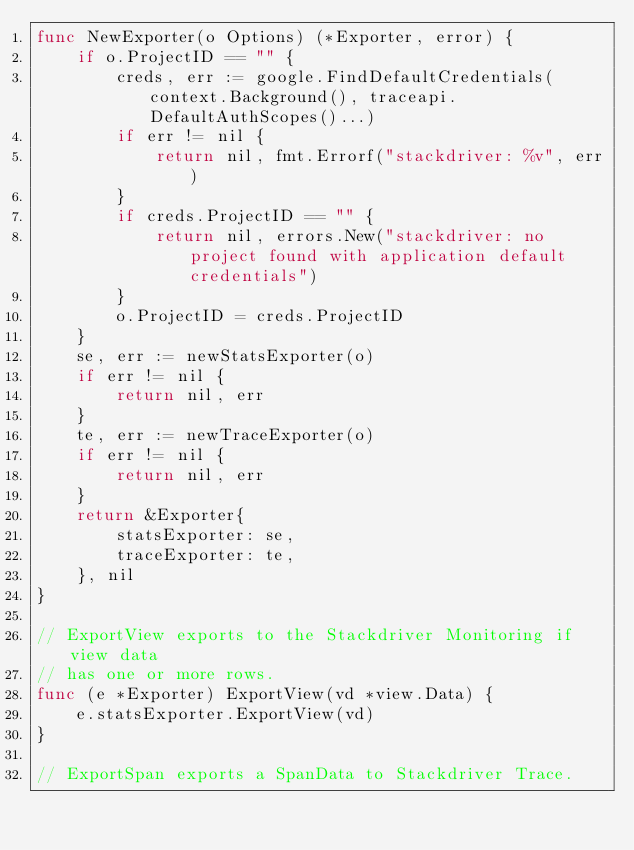Convert code to text. <code><loc_0><loc_0><loc_500><loc_500><_Go_>func NewExporter(o Options) (*Exporter, error) {
	if o.ProjectID == "" {
		creds, err := google.FindDefaultCredentials(context.Background(), traceapi.DefaultAuthScopes()...)
		if err != nil {
			return nil, fmt.Errorf("stackdriver: %v", err)
		}
		if creds.ProjectID == "" {
			return nil, errors.New("stackdriver: no project found with application default credentials")
		}
		o.ProjectID = creds.ProjectID
	}
	se, err := newStatsExporter(o)
	if err != nil {
		return nil, err
	}
	te, err := newTraceExporter(o)
	if err != nil {
		return nil, err
	}
	return &Exporter{
		statsExporter: se,
		traceExporter: te,
	}, nil
}

// ExportView exports to the Stackdriver Monitoring if view data
// has one or more rows.
func (e *Exporter) ExportView(vd *view.Data) {
	e.statsExporter.ExportView(vd)
}

// ExportSpan exports a SpanData to Stackdriver Trace.</code> 